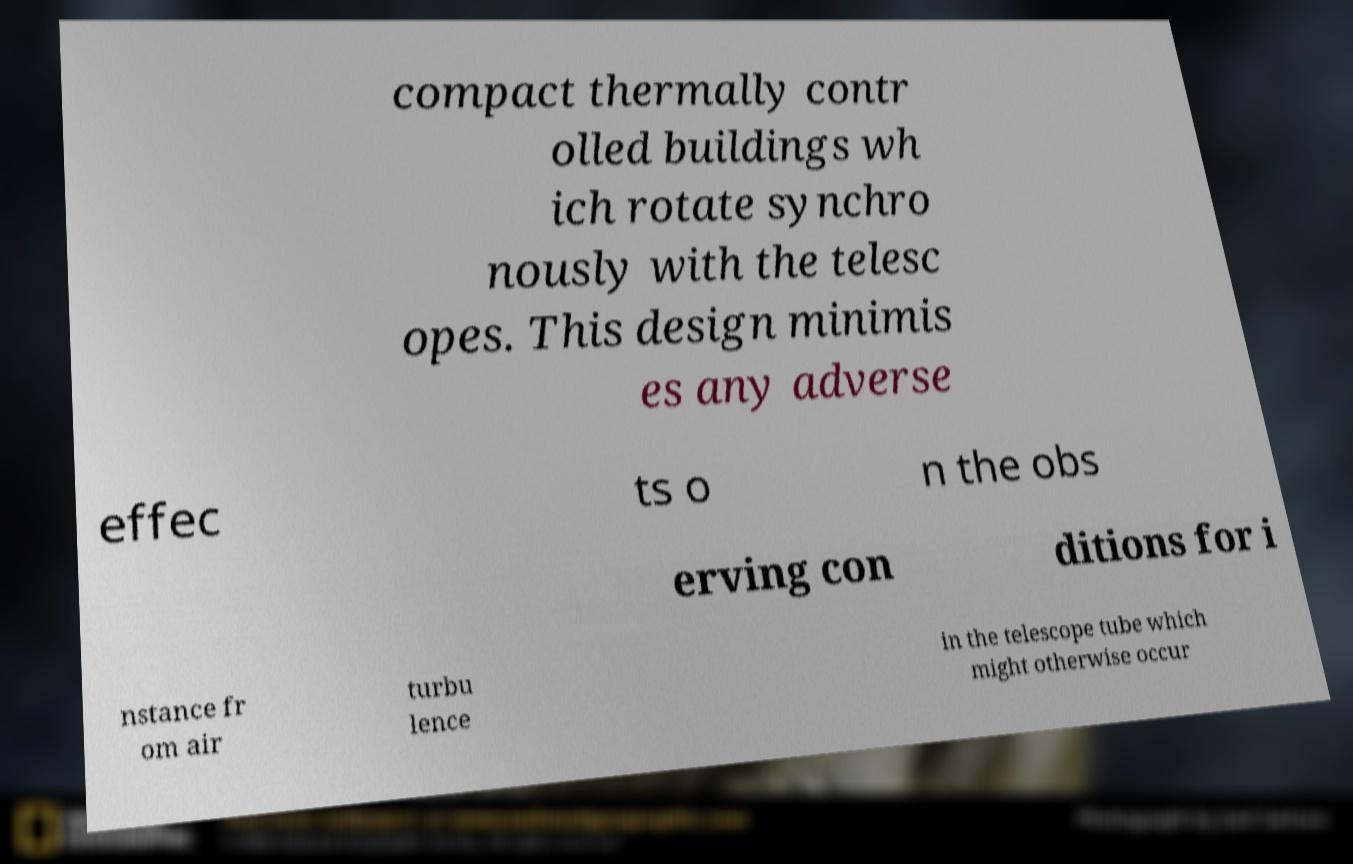Could you assist in decoding the text presented in this image and type it out clearly? compact thermally contr olled buildings wh ich rotate synchro nously with the telesc opes. This design minimis es any adverse effec ts o n the obs erving con ditions for i nstance fr om air turbu lence in the telescope tube which might otherwise occur 